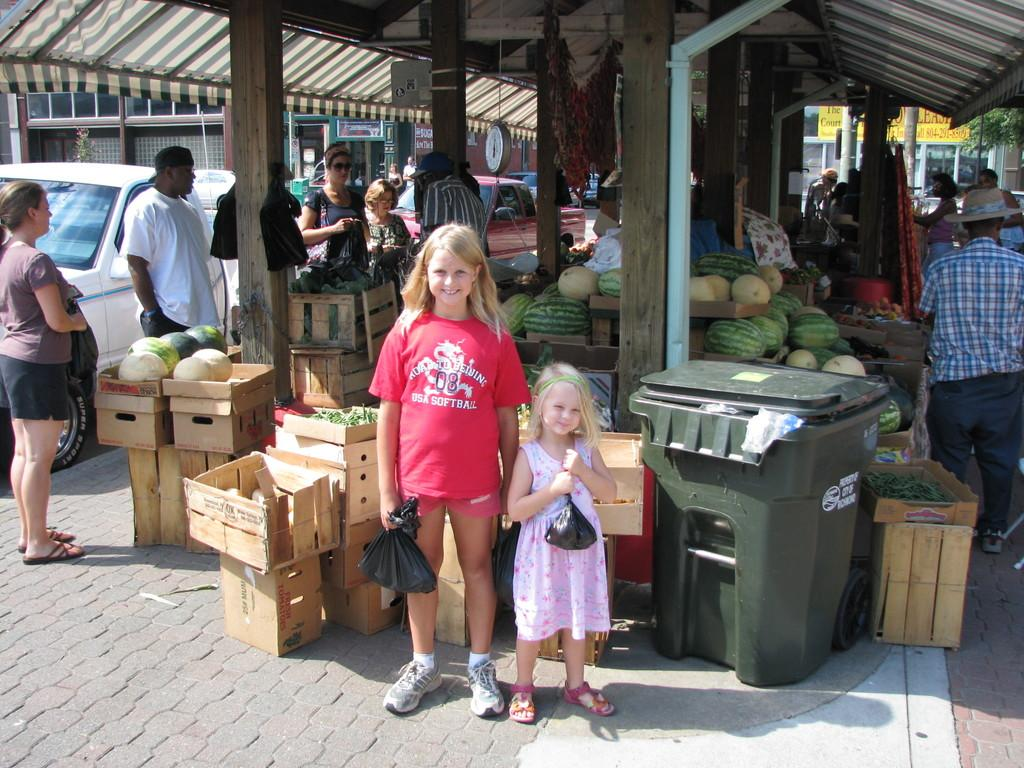<image>
Offer a succinct explanation of the picture presented. A girl wears a red USA Softball t-shirt. 